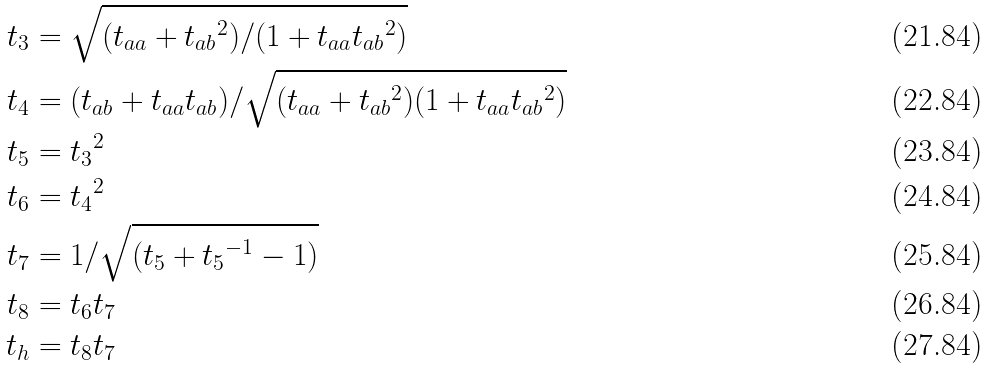<formula> <loc_0><loc_0><loc_500><loc_500>t _ { 3 } & = \sqrt { ( t _ { a a } + { t _ { a b } } ^ { 2 } ) / ( 1 + t _ { a a } { t _ { a b } } ^ { 2 } ) } \\ t _ { 4 } & = ( t _ { a b } + t _ { a a } t _ { a b } ) / \sqrt { ( t _ { a a } + { t _ { a b } } ^ { 2 } ) ( 1 + t _ { a a } { t _ { a b } } ^ { 2 } ) } \\ t _ { 5 } & = { t _ { 3 } } ^ { 2 } \\ t _ { 6 } & = { t _ { 4 } } ^ { 2 } \\ t _ { 7 } & = 1 / \sqrt { ( t _ { 5 } + { t _ { 5 } } ^ { - 1 } - 1 ) } \\ t _ { 8 } & = t _ { 6 } t _ { 7 } \\ t _ { h } & = t _ { 8 } t _ { 7 }</formula> 